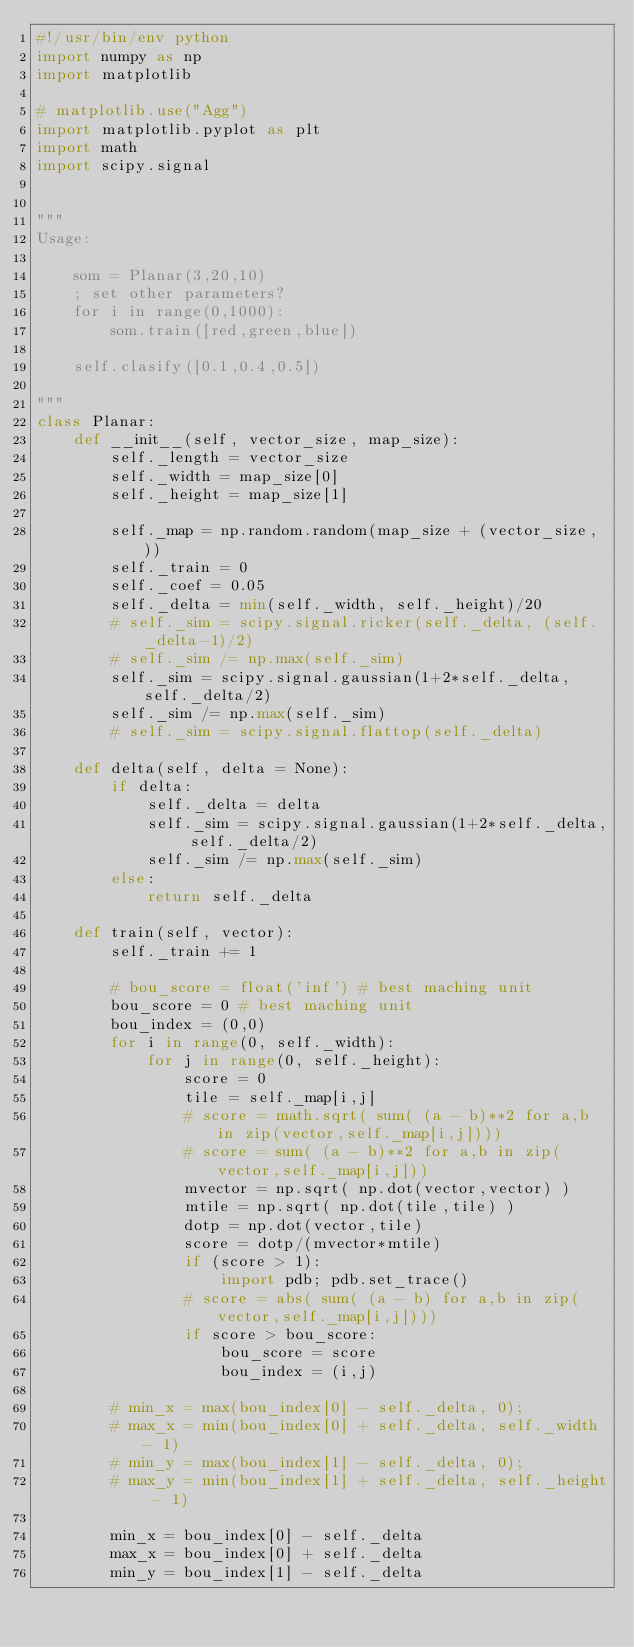<code> <loc_0><loc_0><loc_500><loc_500><_Python_>#!/usr/bin/env python
import numpy as np
import matplotlib

# matplotlib.use("Agg")
import matplotlib.pyplot as plt
import math
import scipy.signal


"""
Usage:

    som = Planar(3,20,10)
    ; set other parameters?
    for i in range(0,1000):
        som.train([red,green,blue])

    self.clasify([0.1,0.4,0.5])

"""
class Planar:
    def __init__(self, vector_size, map_size):
        self._length = vector_size
        self._width = map_size[0]
        self._height = map_size[1]

        self._map = np.random.random(map_size + (vector_size, ))
        self._train = 0
        self._coef = 0.05
        self._delta = min(self._width, self._height)/20
        # self._sim = scipy.signal.ricker(self._delta, (self._delta-1)/2)
        # self._sim /= np.max(self._sim)
        self._sim = scipy.signal.gaussian(1+2*self._delta, self._delta/2)
        self._sim /= np.max(self._sim)
        # self._sim = scipy.signal.flattop(self._delta)

    def delta(self, delta = None):
        if delta:
            self._delta = delta
            self._sim = scipy.signal.gaussian(1+2*self._delta, self._delta/2)
            self._sim /= np.max(self._sim)
        else:
            return self._delta

    def train(self, vector):
        self._train += 1

        # bou_score = float('inf') # best maching unit
        bou_score = 0 # best maching unit
        bou_index = (0,0)
        for i in range(0, self._width):
            for j in range(0, self._height):
                score = 0
                tile = self._map[i,j]
                # score = math.sqrt( sum( (a - b)**2 for a,b in zip(vector,self._map[i,j])))
                # score = sum( (a - b)**2 for a,b in zip(vector,self._map[i,j]))
                mvector = np.sqrt( np.dot(vector,vector) )
                mtile = np.sqrt( np.dot(tile,tile) )
                dotp = np.dot(vector,tile)
                score = dotp/(mvector*mtile)
                if (score > 1):
                    import pdb; pdb.set_trace()
                # score = abs( sum( (a - b) for a,b in zip(vector,self._map[i,j])))
                if score > bou_score:
                    bou_score = score
                    bou_index = (i,j)

        # min_x = max(bou_index[0] - self._delta, 0);
        # max_x = min(bou_index[0] + self._delta, self._width - 1)
        # min_y = max(bou_index[1] - self._delta, 0);
        # max_y = min(bou_index[1] + self._delta, self._height - 1)

        min_x = bou_index[0] - self._delta
        max_x = bou_index[0] + self._delta
        min_y = bou_index[1] - self._delta</code> 